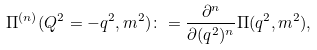<formula> <loc_0><loc_0><loc_500><loc_500>\Pi ^ { ( n ) } ( Q ^ { 2 } = - q ^ { 2 } , m ^ { 2 } ) \colon = \frac { \partial ^ { n } } { \partial ( q ^ { 2 } ) ^ { n } } \Pi ( q ^ { 2 } , m ^ { 2 } ) ,</formula> 